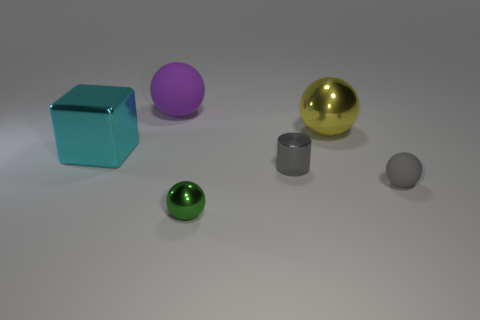Subtract all gray balls. How many balls are left? 3 Add 2 tiny brown objects. How many objects exist? 8 Subtract all large yellow metal spheres. How many spheres are left? 3 Subtract 2 spheres. How many spheres are left? 2 Subtract all blue spheres. Subtract all purple cubes. How many spheres are left? 4 Subtract all spheres. How many objects are left? 2 Add 6 tiny purple cylinders. How many tiny purple cylinders exist? 6 Subtract 0 brown cubes. How many objects are left? 6 Subtract all gray balls. Subtract all tiny gray cylinders. How many objects are left? 4 Add 5 big purple rubber objects. How many big purple rubber objects are left? 6 